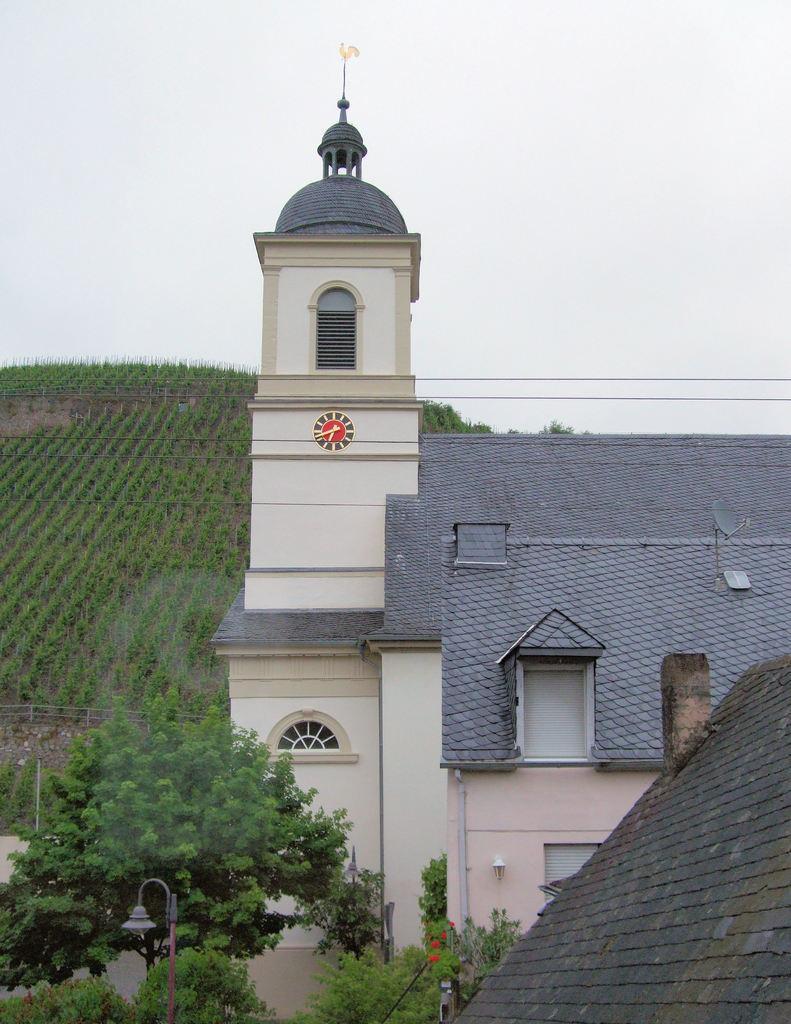Can you describe this image briefly? In this picture I see the buildings in front and I see number of trees and a pole. In the background I see the plants and the sky. 